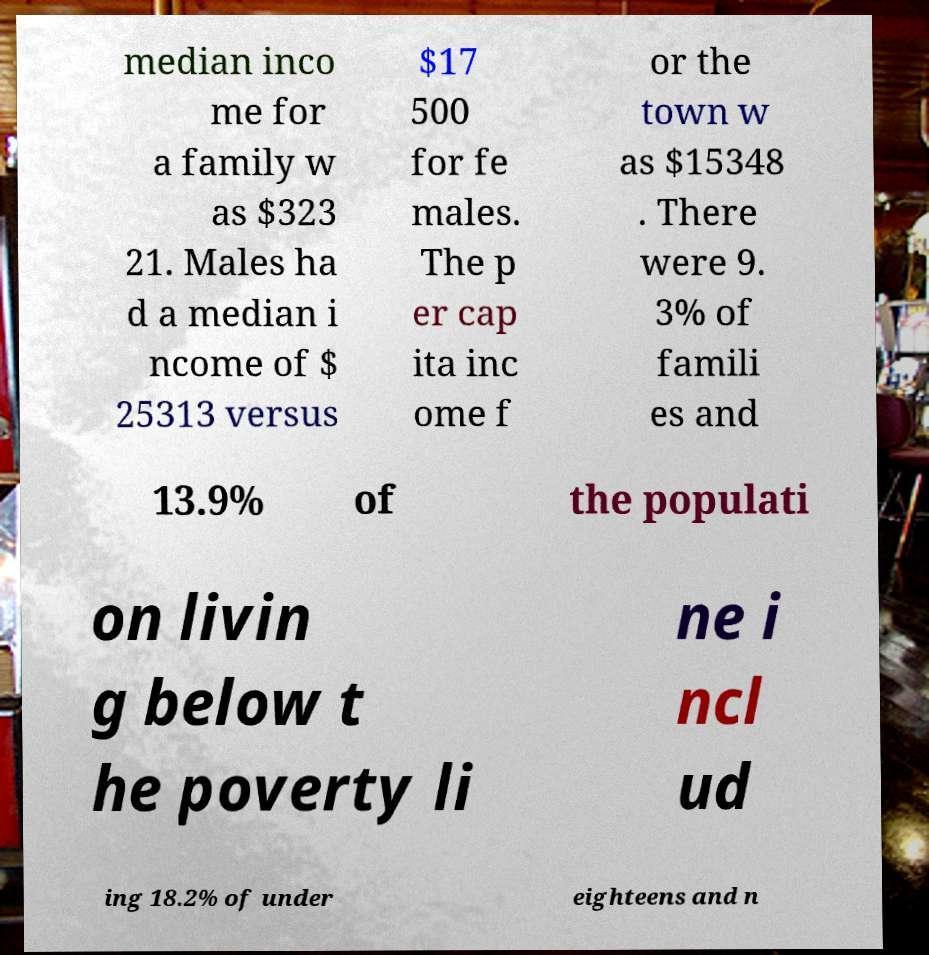What messages or text are displayed in this image? I need them in a readable, typed format. median inco me for a family w as $323 21. Males ha d a median i ncome of $ 25313 versus $17 500 for fe males. The p er cap ita inc ome f or the town w as $15348 . There were 9. 3% of famili es and 13.9% of the populati on livin g below t he poverty li ne i ncl ud ing 18.2% of under eighteens and n 